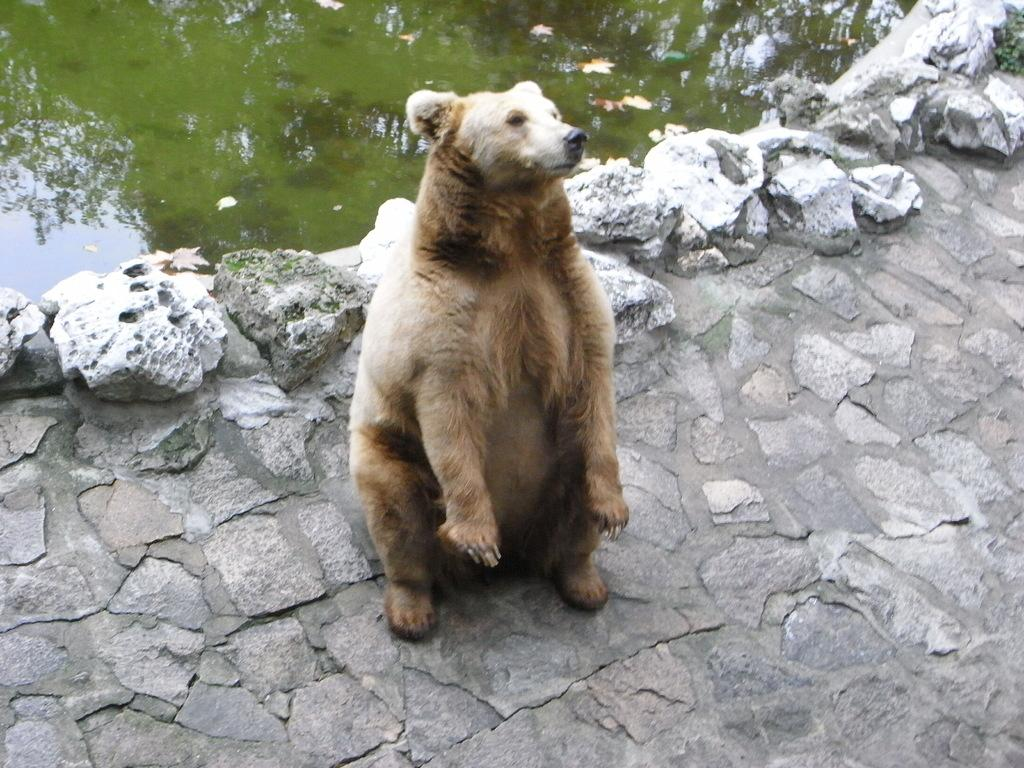What animal is in the foreground of the image? There is a polar bear in the foreground of the image. What can be seen in the background of the image? There is a water body in the background of the image. What type of soap is the polar bear using to clean itself in the image? There is no soap present in the image, and the polar bear is not shown cleaning itself. 